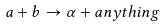Convert formula to latex. <formula><loc_0><loc_0><loc_500><loc_500>a + b \rightarrow \alpha + a n y t h i n g</formula> 